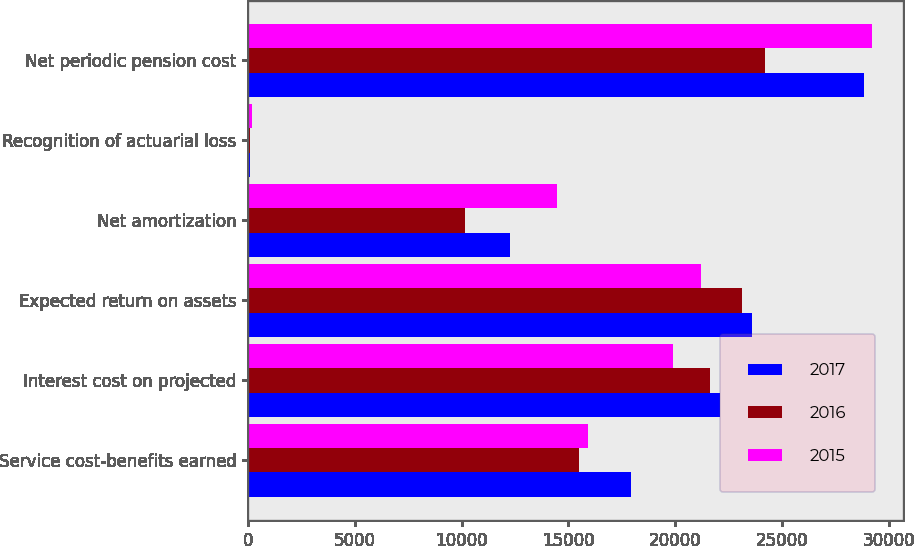<chart> <loc_0><loc_0><loc_500><loc_500><stacked_bar_chart><ecel><fcel>Service cost-benefits earned<fcel>Interest cost on projected<fcel>Expected return on assets<fcel>Net amortization<fcel>Recognition of actuarial loss<fcel>Net periodic pension cost<nl><fcel>2017<fcel>17942<fcel>22124<fcel>23597<fcel>12281<fcel>78<fcel>28828<nl><fcel>2016<fcel>15502<fcel>21631<fcel>23127<fcel>10135<fcel>61<fcel>24202<nl><fcel>2015<fcel>15902<fcel>19887<fcel>21204<fcel>14465<fcel>180<fcel>29230<nl></chart> 